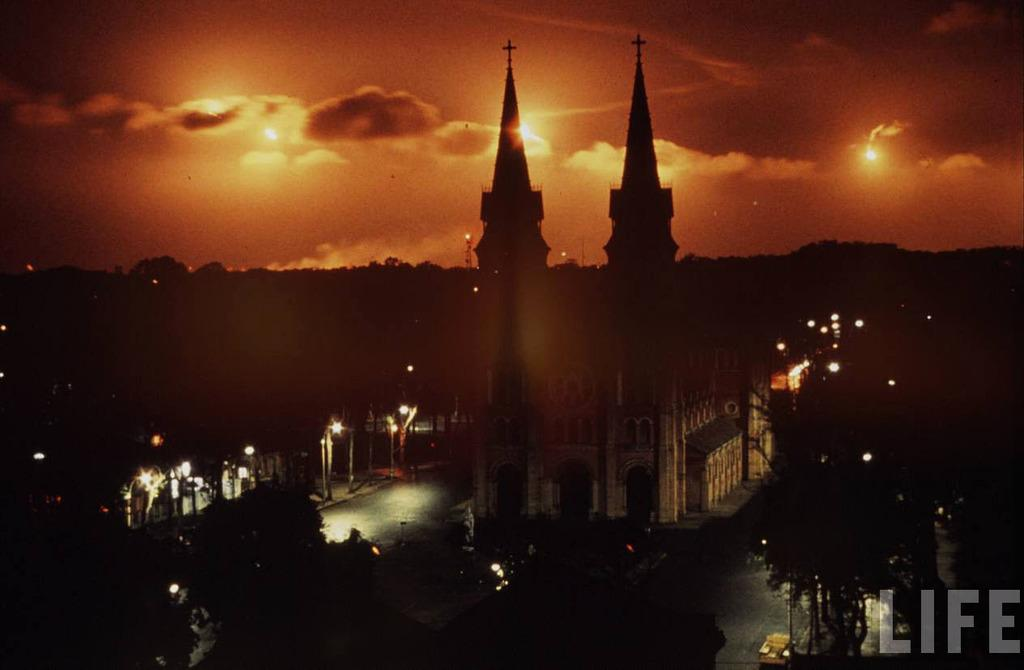What type of building is depicted in the image? The building in the image has two cross symbols at the top. What can be seen in the background of the image? There are trees visible in the image. What type of infrastructure is present in the image? There are lights on electric poles in the image. What is visible in the sky in the image? There are clouds in the sky in the image. What type of curtain is hanging in the building in the image? There is no curtain visible in the image; the focus is on the building and its surroundings. 